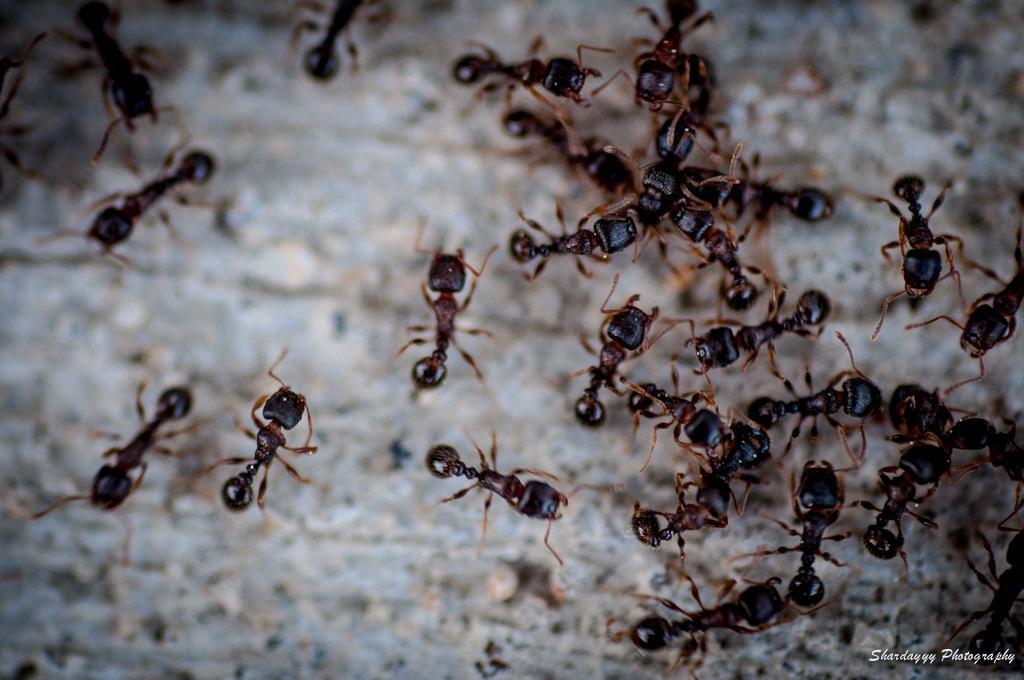Describe this image in one or two sentences. In this image we can see the ants on the ground. 